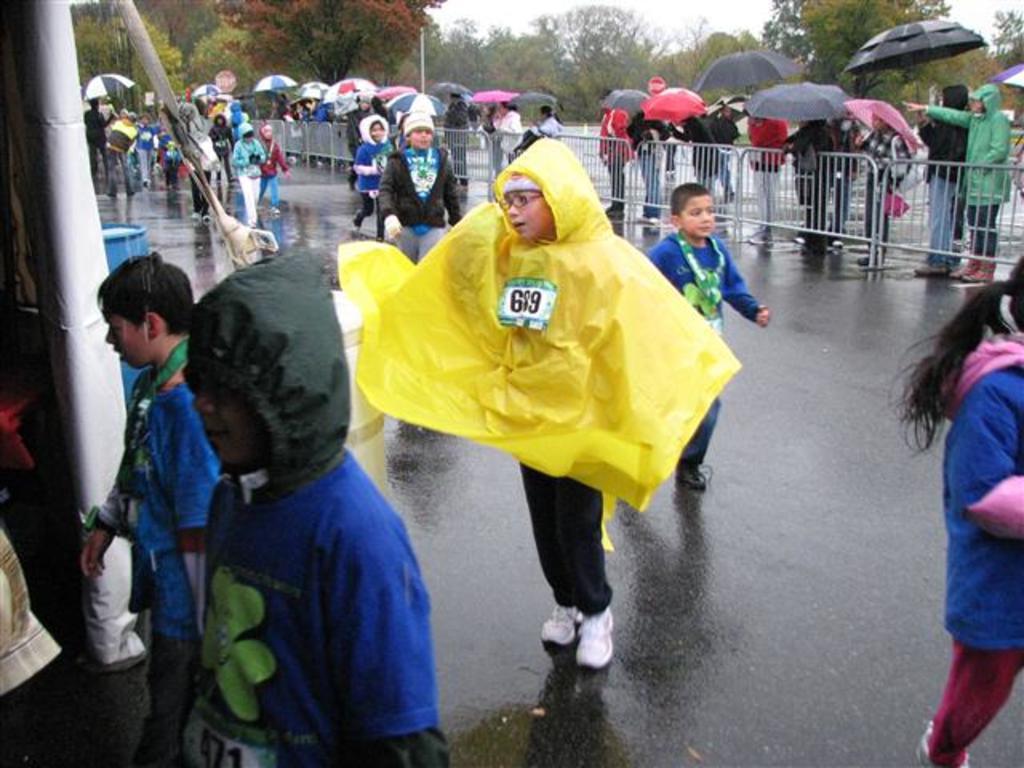Describe this image in one or two sentences. At the bottom of the image I can see the road. In the picture I can see children holding the umbrellas. In the background, I can see groups of trees. 